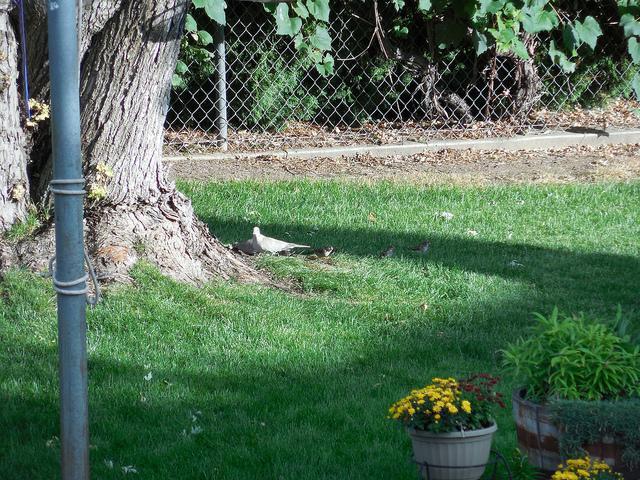How many birds are in this photo?
Give a very brief answer. 1. How many potted plants can you see?
Give a very brief answer. 2. How many people are holding a yellow board?
Give a very brief answer. 0. 